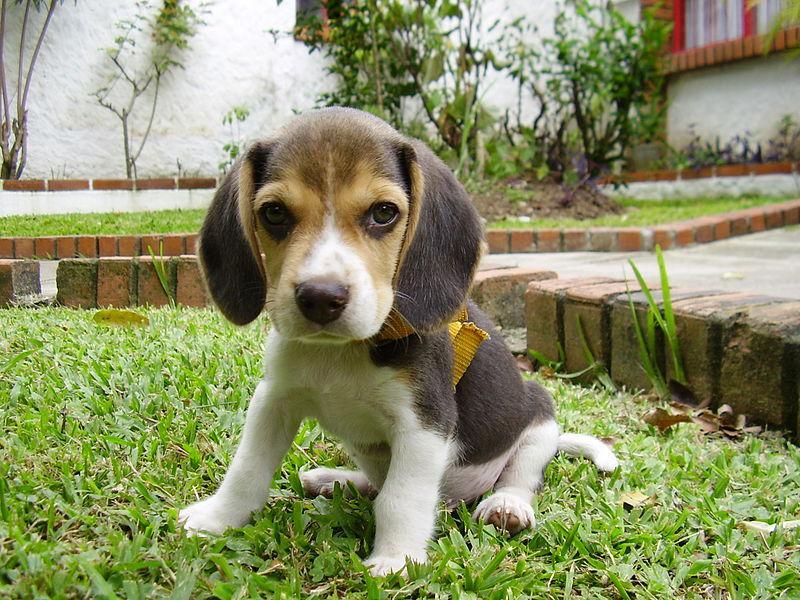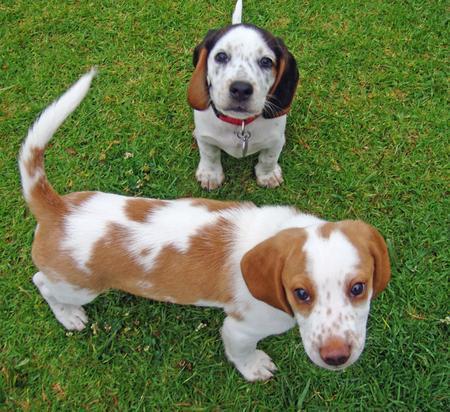The first image is the image on the left, the second image is the image on the right. Evaluate the accuracy of this statement regarding the images: "A dog in one image has a toy in his mouth.". Is it true? Answer yes or no. No. 